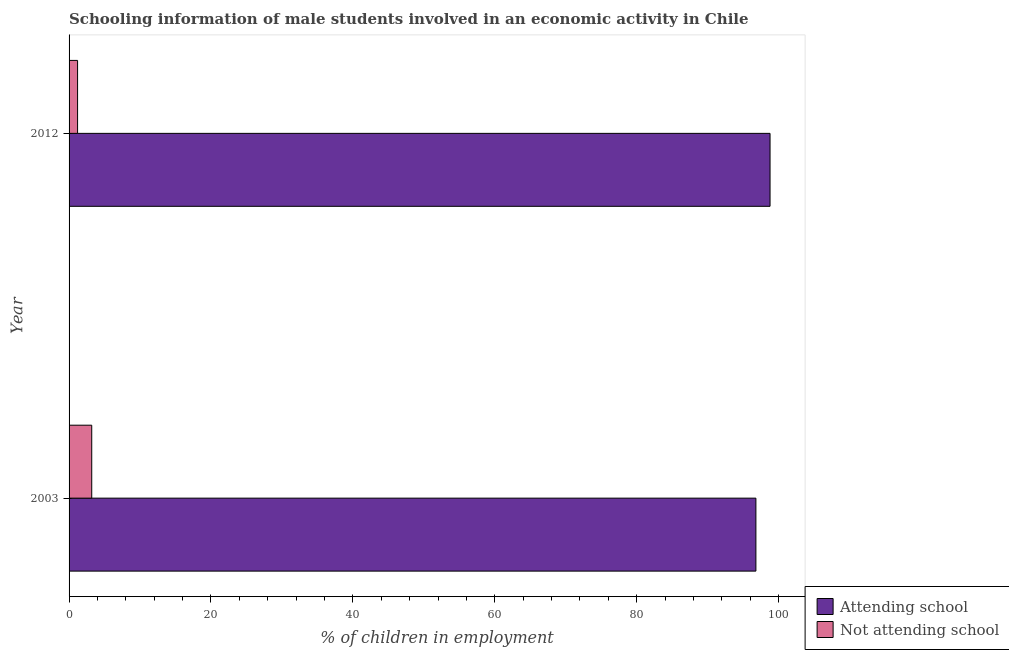How many different coloured bars are there?
Ensure brevity in your answer.  2. Are the number of bars per tick equal to the number of legend labels?
Your answer should be very brief. Yes. How many bars are there on the 2nd tick from the bottom?
Offer a terse response. 2. What is the percentage of employed males who are attending school in 2003?
Your response must be concise. 96.81. Across all years, what is the maximum percentage of employed males who are attending school?
Provide a succinct answer. 98.8. Across all years, what is the minimum percentage of employed males who are attending school?
Make the answer very short. 96.81. In which year was the percentage of employed males who are not attending school maximum?
Your answer should be very brief. 2003. In which year was the percentage of employed males who are attending school minimum?
Keep it short and to the point. 2003. What is the total percentage of employed males who are attending school in the graph?
Give a very brief answer. 195.61. What is the difference between the percentage of employed males who are not attending school in 2003 and that in 2012?
Your answer should be very brief. 1.99. What is the difference between the percentage of employed males who are attending school in 2003 and the percentage of employed males who are not attending school in 2012?
Keep it short and to the point. 95.61. What is the average percentage of employed males who are attending school per year?
Offer a terse response. 97.8. In the year 2012, what is the difference between the percentage of employed males who are not attending school and percentage of employed males who are attending school?
Make the answer very short. -97.6. In how many years, is the percentage of employed males who are not attending school greater than 80 %?
Offer a very short reply. 0. What is the ratio of the percentage of employed males who are not attending school in 2003 to that in 2012?
Give a very brief answer. 2.66. Is the difference between the percentage of employed males who are not attending school in 2003 and 2012 greater than the difference between the percentage of employed males who are attending school in 2003 and 2012?
Provide a short and direct response. Yes. In how many years, is the percentage of employed males who are not attending school greater than the average percentage of employed males who are not attending school taken over all years?
Provide a succinct answer. 1. What does the 1st bar from the top in 2003 represents?
Make the answer very short. Not attending school. What does the 1st bar from the bottom in 2003 represents?
Offer a terse response. Attending school. How many bars are there?
Make the answer very short. 4. Are the values on the major ticks of X-axis written in scientific E-notation?
Make the answer very short. No. Does the graph contain grids?
Provide a short and direct response. No. How are the legend labels stacked?
Your answer should be very brief. Vertical. What is the title of the graph?
Ensure brevity in your answer.  Schooling information of male students involved in an economic activity in Chile. Does "Subsidies" appear as one of the legend labels in the graph?
Provide a short and direct response. No. What is the label or title of the X-axis?
Keep it short and to the point. % of children in employment. What is the label or title of the Y-axis?
Offer a terse response. Year. What is the % of children in employment of Attending school in 2003?
Provide a succinct answer. 96.81. What is the % of children in employment of Not attending school in 2003?
Your response must be concise. 3.19. What is the % of children in employment of Attending school in 2012?
Your answer should be very brief. 98.8. What is the % of children in employment in Not attending school in 2012?
Offer a very short reply. 1.2. Across all years, what is the maximum % of children in employment in Attending school?
Make the answer very short. 98.8. Across all years, what is the maximum % of children in employment in Not attending school?
Your answer should be very brief. 3.19. Across all years, what is the minimum % of children in employment of Attending school?
Give a very brief answer. 96.81. Across all years, what is the minimum % of children in employment of Not attending school?
Provide a succinct answer. 1.2. What is the total % of children in employment of Attending school in the graph?
Make the answer very short. 195.61. What is the total % of children in employment in Not attending school in the graph?
Your answer should be compact. 4.39. What is the difference between the % of children in employment in Attending school in 2003 and that in 2012?
Provide a short and direct response. -1.99. What is the difference between the % of children in employment in Not attending school in 2003 and that in 2012?
Provide a succinct answer. 1.99. What is the difference between the % of children in employment of Attending school in 2003 and the % of children in employment of Not attending school in 2012?
Keep it short and to the point. 95.61. What is the average % of children in employment in Attending school per year?
Your answer should be compact. 97.8. What is the average % of children in employment of Not attending school per year?
Keep it short and to the point. 2.2. In the year 2003, what is the difference between the % of children in employment in Attending school and % of children in employment in Not attending school?
Ensure brevity in your answer.  93.61. In the year 2012, what is the difference between the % of children in employment of Attending school and % of children in employment of Not attending school?
Your answer should be very brief. 97.6. What is the ratio of the % of children in employment of Attending school in 2003 to that in 2012?
Your answer should be compact. 0.98. What is the ratio of the % of children in employment in Not attending school in 2003 to that in 2012?
Offer a very short reply. 2.66. What is the difference between the highest and the second highest % of children in employment of Attending school?
Offer a very short reply. 1.99. What is the difference between the highest and the second highest % of children in employment in Not attending school?
Offer a very short reply. 1.99. What is the difference between the highest and the lowest % of children in employment in Attending school?
Make the answer very short. 1.99. What is the difference between the highest and the lowest % of children in employment in Not attending school?
Make the answer very short. 1.99. 